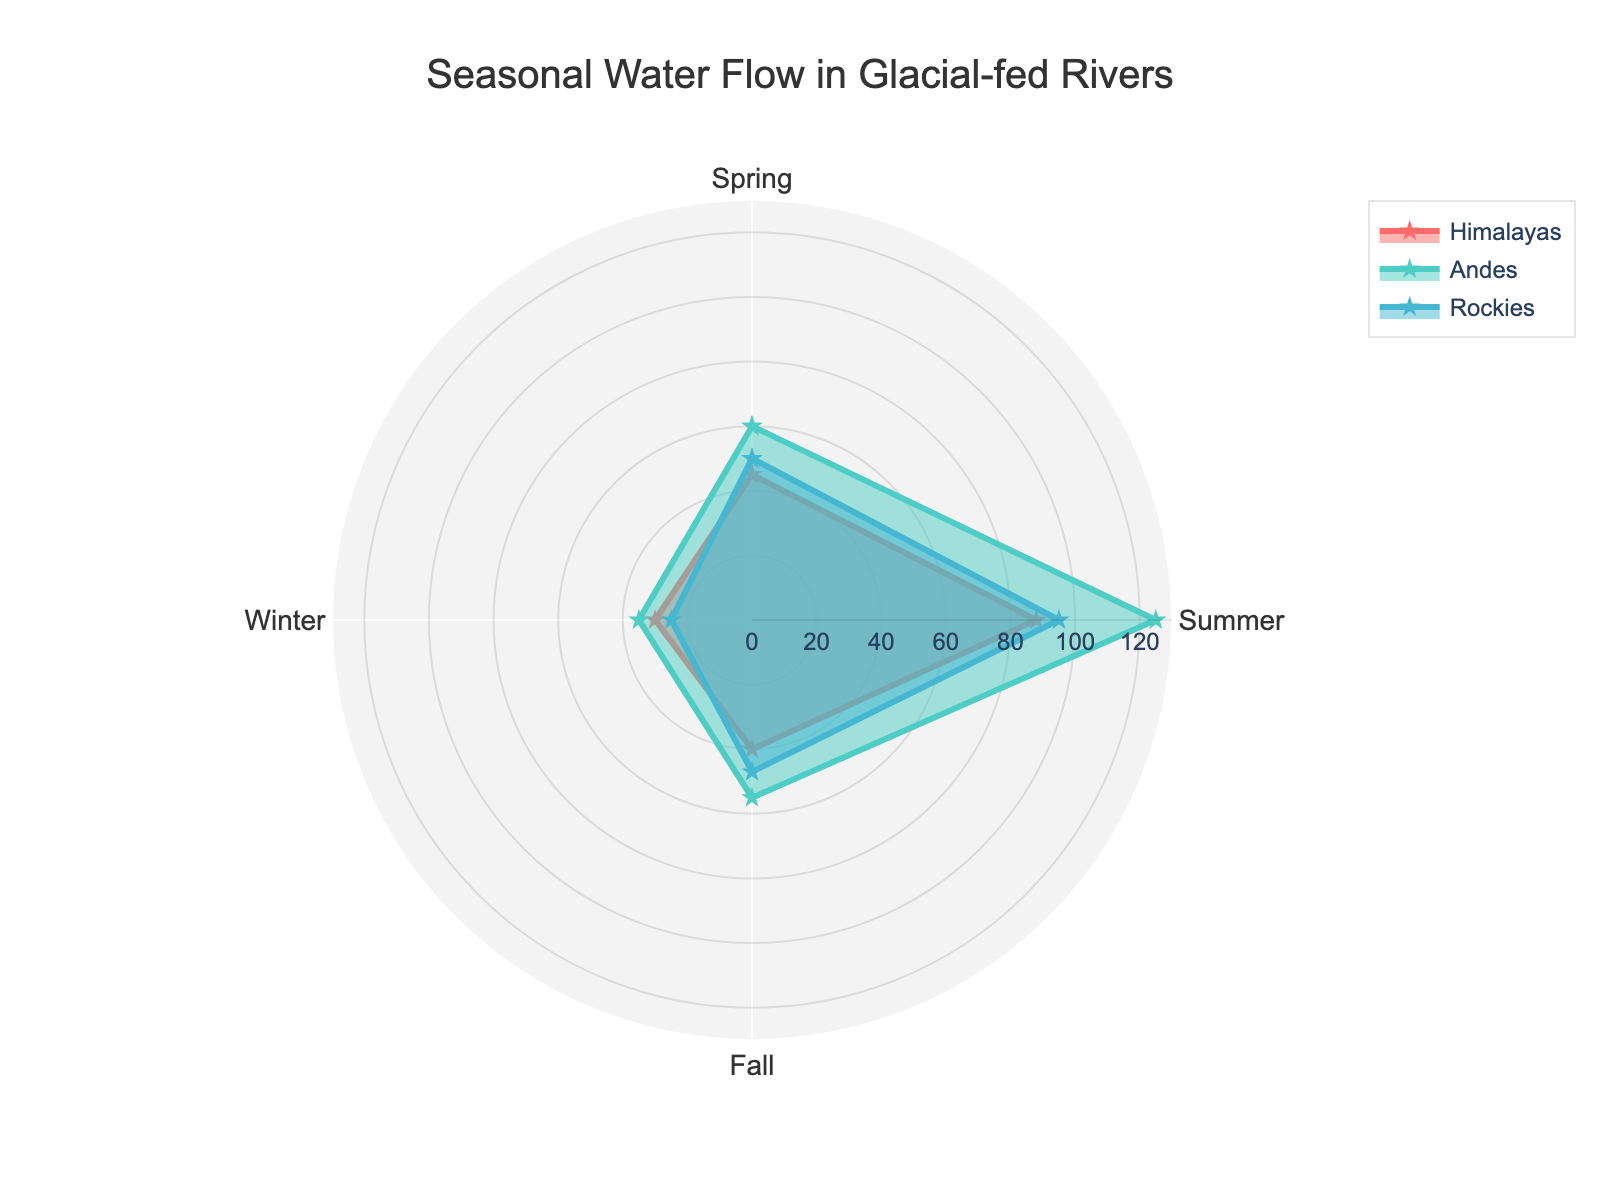Which region shows the highest water flow in Summer? In the radar chart, the Summer water flow is represented for each region. The highest point in Summer corresponds to the Andes with a water flow of 125 cubic meters per second.
Answer: Andes Which season has the lowest water flow for the Himalayas? To determine the lowest flow, look at the water flows for Spring, Summer, Fall, and Winter. The lowest flow is in Winter, with 30 cubic meters per second.
Answer: Winter What is the difference in water flow between Summer and Winter for the Rockies? Check the flow values for Summer (95) and Winter (25). The difference is calculated as 95 - 25 = 70 cubic meters per second.
Answer: 70 How does the Fall water flow in the Andes compare to that in the Rockies? The Fall water flow for the Andes is 55, while for the Rockies, it is 47. The Andes have a higher Fall water flow compared to the Rockies.
Answer: Andes is higher Which region has the smallest range in water flow across all seasons? To find the range, subtract the lowest value from the highest for each region: Himalayas (88-30=58), Andes (125-35=90), Rockies (95-25=70), and compare them. The smallest range is for the Himalayas with 58.
Answer: Himalayas On which season do all regions have the most similar water flow? Comparing each season's flow: Spring (Himalayas: 45, Andes: 60, Rockies: 50), Summer (Himalayas: 88, Andes: 125, Rockies: 95), Fall (Himalayas: 40, Andes: 55, Rockies: 47), Winter (Himalayas: 30, Andes: 35, Rockies: 25), the flows are most similar in Winter with values 30, 35, and 25.
Answer: Winter What is the average water flow in Fall across all regions? Sum the Fall flow values for the Himalayas (40), Andes (55), and Rockies (47): 40 + 55 + 47 = 142. Then, average it by dividing by the number of regions: 142 / 3 ≈ 47.33 cubic meters per second.
Answer: 47.33 Which region exhibits the largest increase in water flow from Spring to Summer? Calculate the increase from Spring to Summer for each: Himalayas (88-45=43), Andes (125-60=65), Rockies (95-50=45). The largest increase is shown by the Andes with 65.
Answer: Andes 